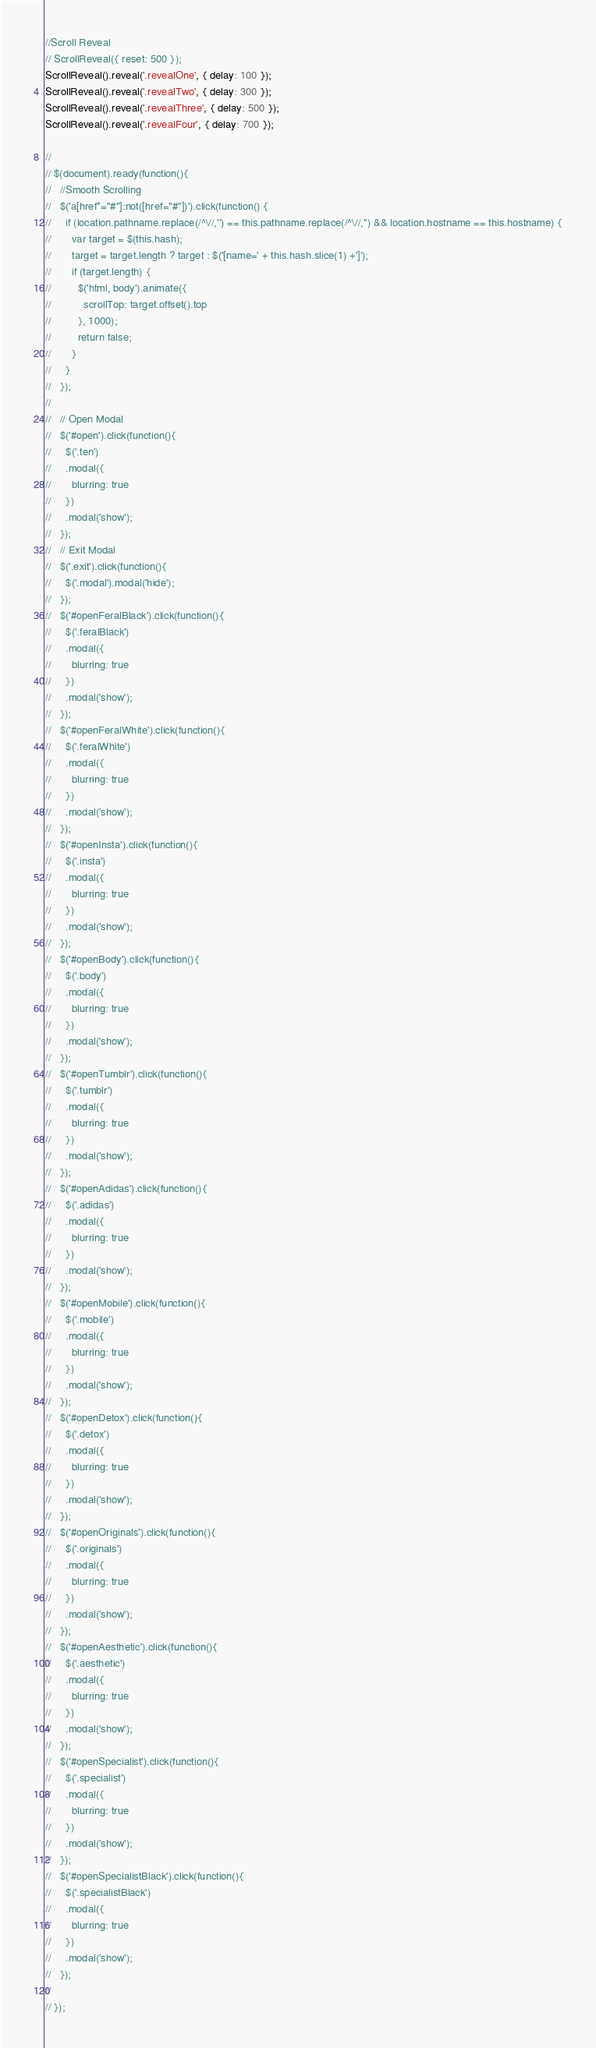<code> <loc_0><loc_0><loc_500><loc_500><_JavaScript_>//Scroll Reveal
// ScrollReveal({ reset: 500 });
ScrollReveal().reveal('.revealOne', { delay: 100 });
ScrollReveal().reveal('.revealTwo', { delay: 300 });
ScrollReveal().reveal('.revealThree', { delay: 500 });
ScrollReveal().reveal('.revealFour', { delay: 700 });

//
// $(document).ready(function(){
//   //Smooth Scrolling
//   $('a[href*="#"]:not([href="#"])').click(function() {
//     if (location.pathname.replace(/^\//,'') == this.pathname.replace(/^\//,'') && location.hostname == this.hostname) {
//       var target = $(this.hash);
//       target = target.length ? target : $('[name=' + this.hash.slice(1) +']');
//       if (target.length) {
//         $('html, body').animate({
//           scrollTop: target.offset().top
//         }, 1000);
//         return false;
//       }
//     }
//   });
//
//   // Open Modal
//   $('#open').click(function(){
//     $('.ten')
//     .modal({
//       blurring: true
//     })
//     .modal('show');
//   });
//   // Exit Modal
//   $('.exit').click(function(){
//     $('.modal').modal('hide');
//   });
//   $('#openFeralBlack').click(function(){
//     $('.feralBlack')
//     .modal({
//       blurring: true
//     })
//     .modal('show');
//   });
//   $('#openFeralWhite').click(function(){
//     $('.feralWhite')
//     .modal({
//       blurring: true
//     })
//     .modal('show');
//   });
//   $('#openInsta').click(function(){
//     $('.insta')
//     .modal({
//       blurring: true
//     })
//     .modal('show');
//   });
//   $('#openBody').click(function(){
//     $('.body')
//     .modal({
//       blurring: true
//     })
//     .modal('show');
//   });
//   $('#openTumblr').click(function(){
//     $('.tumblr')
//     .modal({
//       blurring: true
//     })
//     .modal('show');
//   });
//   $('#openAdidas').click(function(){
//     $('.adidas')
//     .modal({
//       blurring: true
//     })
//     .modal('show');
//   });
//   $('#openMobile').click(function(){
//     $('.mobile')
//     .modal({
//       blurring: true
//     })
//     .modal('show');
//   });
//   $('#openDetox').click(function(){
//     $('.detox')
//     .modal({
//       blurring: true
//     })
//     .modal('show');
//   });
//   $('#openOriginals').click(function(){
//     $('.originals')
//     .modal({
//       blurring: true
//     })
//     .modal('show');
//   });
//   $('#openAesthetic').click(function(){
//     $('.aesthetic')
//     .modal({
//       blurring: true
//     })
//     .modal('show');
//   });
//   $('#openSpecialist').click(function(){
//     $('.specialist')
//     .modal({
//       blurring: true
//     })
//     .modal('show');
//   });
//   $('#openSpecialistBlack').click(function(){
//     $('.specialistBlack')
//     .modal({
//       blurring: true
//     })
//     .modal('show');
//   });
//
// });
</code> 